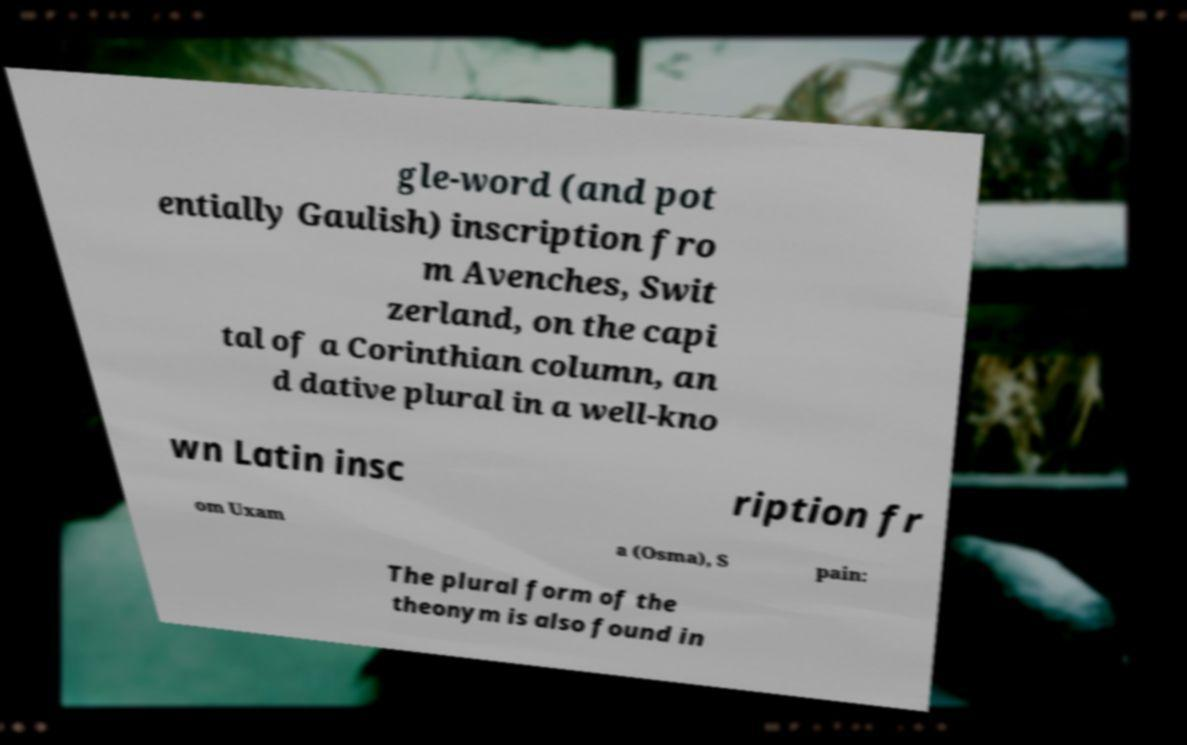What messages or text are displayed in this image? I need them in a readable, typed format. gle-word (and pot entially Gaulish) inscription fro m Avenches, Swit zerland, on the capi tal of a Corinthian column, an d dative plural in a well-kno wn Latin insc ription fr om Uxam a (Osma), S pain: The plural form of the theonym is also found in 